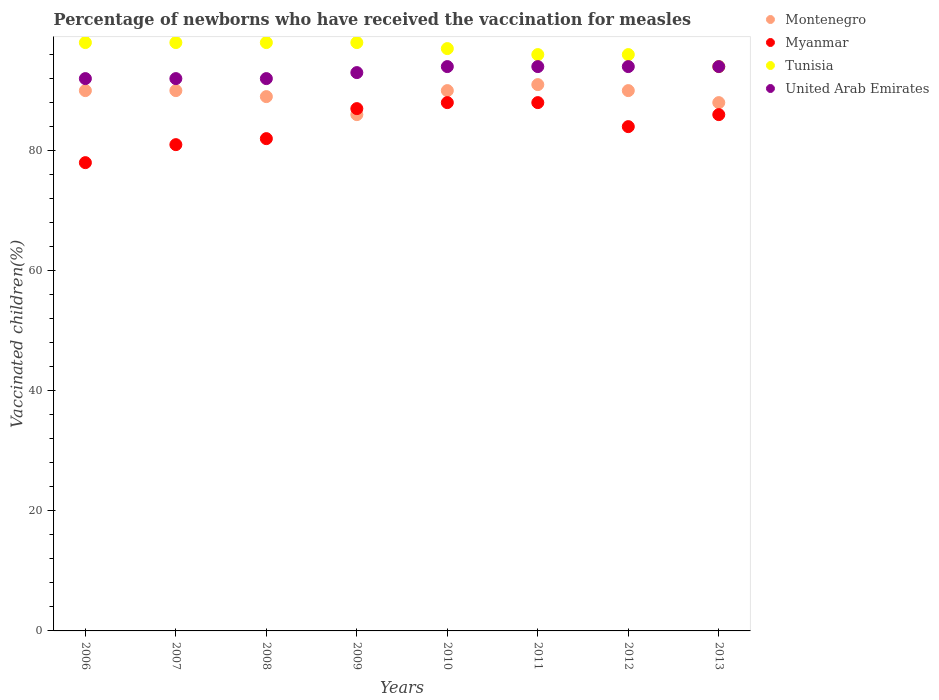How many different coloured dotlines are there?
Provide a short and direct response. 4. What is the percentage of vaccinated children in United Arab Emirates in 2009?
Make the answer very short. 93. In which year was the percentage of vaccinated children in Montenegro maximum?
Provide a succinct answer. 2011. What is the total percentage of vaccinated children in Montenegro in the graph?
Provide a short and direct response. 714. What is the difference between the percentage of vaccinated children in Montenegro in 2006 and that in 2010?
Keep it short and to the point. 0. What is the difference between the percentage of vaccinated children in Myanmar in 2011 and the percentage of vaccinated children in United Arab Emirates in 2008?
Keep it short and to the point. -4. What is the average percentage of vaccinated children in Montenegro per year?
Offer a terse response. 89.25. In how many years, is the percentage of vaccinated children in United Arab Emirates greater than 72 %?
Provide a succinct answer. 8. What is the difference between the highest and the second highest percentage of vaccinated children in Myanmar?
Offer a very short reply. 0. In how many years, is the percentage of vaccinated children in Montenegro greater than the average percentage of vaccinated children in Montenegro taken over all years?
Offer a very short reply. 5. Is the sum of the percentage of vaccinated children in United Arab Emirates in 2008 and 2009 greater than the maximum percentage of vaccinated children in Myanmar across all years?
Your response must be concise. Yes. Is it the case that in every year, the sum of the percentage of vaccinated children in United Arab Emirates and percentage of vaccinated children in Myanmar  is greater than the sum of percentage of vaccinated children in Montenegro and percentage of vaccinated children in Tunisia?
Offer a very short reply. No. Is the percentage of vaccinated children in Montenegro strictly less than the percentage of vaccinated children in Myanmar over the years?
Keep it short and to the point. No. How many dotlines are there?
Your response must be concise. 4. What is the difference between two consecutive major ticks on the Y-axis?
Your answer should be compact. 20. Does the graph contain any zero values?
Keep it short and to the point. No. How are the legend labels stacked?
Your answer should be compact. Vertical. What is the title of the graph?
Keep it short and to the point. Percentage of newborns who have received the vaccination for measles. Does "Luxembourg" appear as one of the legend labels in the graph?
Make the answer very short. No. What is the label or title of the X-axis?
Your answer should be compact. Years. What is the label or title of the Y-axis?
Ensure brevity in your answer.  Vaccinated children(%). What is the Vaccinated children(%) of Montenegro in 2006?
Your answer should be very brief. 90. What is the Vaccinated children(%) in Myanmar in 2006?
Offer a very short reply. 78. What is the Vaccinated children(%) in United Arab Emirates in 2006?
Your response must be concise. 92. What is the Vaccinated children(%) of Montenegro in 2007?
Offer a very short reply. 90. What is the Vaccinated children(%) of Tunisia in 2007?
Your answer should be very brief. 98. What is the Vaccinated children(%) in United Arab Emirates in 2007?
Keep it short and to the point. 92. What is the Vaccinated children(%) in Montenegro in 2008?
Your answer should be very brief. 89. What is the Vaccinated children(%) in United Arab Emirates in 2008?
Offer a terse response. 92. What is the Vaccinated children(%) of Montenegro in 2009?
Your answer should be compact. 86. What is the Vaccinated children(%) in Myanmar in 2009?
Give a very brief answer. 87. What is the Vaccinated children(%) of Tunisia in 2009?
Offer a terse response. 98. What is the Vaccinated children(%) of United Arab Emirates in 2009?
Provide a succinct answer. 93. What is the Vaccinated children(%) of Myanmar in 2010?
Offer a terse response. 88. What is the Vaccinated children(%) of Tunisia in 2010?
Your answer should be very brief. 97. What is the Vaccinated children(%) of United Arab Emirates in 2010?
Provide a short and direct response. 94. What is the Vaccinated children(%) in Montenegro in 2011?
Your answer should be compact. 91. What is the Vaccinated children(%) in Tunisia in 2011?
Offer a terse response. 96. What is the Vaccinated children(%) in United Arab Emirates in 2011?
Your answer should be compact. 94. What is the Vaccinated children(%) in Montenegro in 2012?
Your answer should be compact. 90. What is the Vaccinated children(%) in Myanmar in 2012?
Provide a short and direct response. 84. What is the Vaccinated children(%) in Tunisia in 2012?
Offer a very short reply. 96. What is the Vaccinated children(%) in United Arab Emirates in 2012?
Keep it short and to the point. 94. What is the Vaccinated children(%) in Montenegro in 2013?
Ensure brevity in your answer.  88. What is the Vaccinated children(%) of Tunisia in 2013?
Your answer should be compact. 94. What is the Vaccinated children(%) of United Arab Emirates in 2013?
Your response must be concise. 94. Across all years, what is the maximum Vaccinated children(%) of Montenegro?
Give a very brief answer. 91. Across all years, what is the maximum Vaccinated children(%) of Tunisia?
Offer a very short reply. 98. Across all years, what is the maximum Vaccinated children(%) of United Arab Emirates?
Offer a very short reply. 94. Across all years, what is the minimum Vaccinated children(%) of Montenegro?
Provide a short and direct response. 86. Across all years, what is the minimum Vaccinated children(%) in Tunisia?
Your answer should be compact. 94. Across all years, what is the minimum Vaccinated children(%) of United Arab Emirates?
Your answer should be very brief. 92. What is the total Vaccinated children(%) of Montenegro in the graph?
Your answer should be very brief. 714. What is the total Vaccinated children(%) of Myanmar in the graph?
Provide a short and direct response. 674. What is the total Vaccinated children(%) of Tunisia in the graph?
Make the answer very short. 775. What is the total Vaccinated children(%) in United Arab Emirates in the graph?
Provide a short and direct response. 745. What is the difference between the Vaccinated children(%) in Montenegro in 2006 and that in 2007?
Offer a terse response. 0. What is the difference between the Vaccinated children(%) in United Arab Emirates in 2006 and that in 2007?
Your response must be concise. 0. What is the difference between the Vaccinated children(%) of Montenegro in 2006 and that in 2008?
Your answer should be compact. 1. What is the difference between the Vaccinated children(%) of Tunisia in 2006 and that in 2009?
Provide a short and direct response. 0. What is the difference between the Vaccinated children(%) in Myanmar in 2006 and that in 2010?
Your answer should be very brief. -10. What is the difference between the Vaccinated children(%) of Montenegro in 2006 and that in 2011?
Your answer should be compact. -1. What is the difference between the Vaccinated children(%) in Myanmar in 2006 and that in 2011?
Keep it short and to the point. -10. What is the difference between the Vaccinated children(%) in Tunisia in 2006 and that in 2011?
Ensure brevity in your answer.  2. What is the difference between the Vaccinated children(%) in United Arab Emirates in 2006 and that in 2011?
Offer a terse response. -2. What is the difference between the Vaccinated children(%) in Myanmar in 2006 and that in 2012?
Keep it short and to the point. -6. What is the difference between the Vaccinated children(%) in Montenegro in 2007 and that in 2008?
Offer a terse response. 1. What is the difference between the Vaccinated children(%) in Tunisia in 2007 and that in 2008?
Provide a succinct answer. 0. What is the difference between the Vaccinated children(%) in Montenegro in 2007 and that in 2009?
Keep it short and to the point. 4. What is the difference between the Vaccinated children(%) in Tunisia in 2007 and that in 2009?
Offer a very short reply. 0. What is the difference between the Vaccinated children(%) of United Arab Emirates in 2007 and that in 2009?
Your answer should be very brief. -1. What is the difference between the Vaccinated children(%) in Tunisia in 2007 and that in 2010?
Your answer should be very brief. 1. What is the difference between the Vaccinated children(%) in United Arab Emirates in 2007 and that in 2010?
Keep it short and to the point. -2. What is the difference between the Vaccinated children(%) in Montenegro in 2007 and that in 2011?
Offer a very short reply. -1. What is the difference between the Vaccinated children(%) of Myanmar in 2007 and that in 2011?
Your answer should be very brief. -7. What is the difference between the Vaccinated children(%) of United Arab Emirates in 2007 and that in 2011?
Ensure brevity in your answer.  -2. What is the difference between the Vaccinated children(%) in Montenegro in 2007 and that in 2012?
Make the answer very short. 0. What is the difference between the Vaccinated children(%) in Myanmar in 2007 and that in 2012?
Offer a very short reply. -3. What is the difference between the Vaccinated children(%) in Montenegro in 2007 and that in 2013?
Offer a terse response. 2. What is the difference between the Vaccinated children(%) in Myanmar in 2007 and that in 2013?
Your answer should be compact. -5. What is the difference between the Vaccinated children(%) of Montenegro in 2008 and that in 2009?
Offer a very short reply. 3. What is the difference between the Vaccinated children(%) in Myanmar in 2008 and that in 2009?
Your answer should be very brief. -5. What is the difference between the Vaccinated children(%) in Montenegro in 2008 and that in 2010?
Your answer should be compact. -1. What is the difference between the Vaccinated children(%) of Tunisia in 2008 and that in 2010?
Offer a terse response. 1. What is the difference between the Vaccinated children(%) in United Arab Emirates in 2008 and that in 2010?
Your response must be concise. -2. What is the difference between the Vaccinated children(%) in Montenegro in 2008 and that in 2011?
Offer a terse response. -2. What is the difference between the Vaccinated children(%) of Tunisia in 2008 and that in 2011?
Give a very brief answer. 2. What is the difference between the Vaccinated children(%) in Montenegro in 2008 and that in 2012?
Offer a very short reply. -1. What is the difference between the Vaccinated children(%) of Myanmar in 2008 and that in 2012?
Provide a succinct answer. -2. What is the difference between the Vaccinated children(%) of Tunisia in 2008 and that in 2012?
Your answer should be compact. 2. What is the difference between the Vaccinated children(%) of Tunisia in 2008 and that in 2013?
Ensure brevity in your answer.  4. What is the difference between the Vaccinated children(%) of United Arab Emirates in 2009 and that in 2010?
Make the answer very short. -1. What is the difference between the Vaccinated children(%) of Myanmar in 2009 and that in 2011?
Your response must be concise. -1. What is the difference between the Vaccinated children(%) of Tunisia in 2009 and that in 2011?
Provide a short and direct response. 2. What is the difference between the Vaccinated children(%) of United Arab Emirates in 2009 and that in 2011?
Your answer should be very brief. -1. What is the difference between the Vaccinated children(%) in Montenegro in 2009 and that in 2012?
Give a very brief answer. -4. What is the difference between the Vaccinated children(%) in Myanmar in 2009 and that in 2012?
Your answer should be very brief. 3. What is the difference between the Vaccinated children(%) in Montenegro in 2009 and that in 2013?
Provide a short and direct response. -2. What is the difference between the Vaccinated children(%) of United Arab Emirates in 2009 and that in 2013?
Offer a very short reply. -1. What is the difference between the Vaccinated children(%) of Tunisia in 2010 and that in 2011?
Offer a very short reply. 1. What is the difference between the Vaccinated children(%) in Myanmar in 2010 and that in 2012?
Keep it short and to the point. 4. What is the difference between the Vaccinated children(%) in United Arab Emirates in 2010 and that in 2012?
Ensure brevity in your answer.  0. What is the difference between the Vaccinated children(%) of Myanmar in 2010 and that in 2013?
Offer a terse response. 2. What is the difference between the Vaccinated children(%) of Myanmar in 2011 and that in 2012?
Give a very brief answer. 4. What is the difference between the Vaccinated children(%) of Tunisia in 2011 and that in 2012?
Your response must be concise. 0. What is the difference between the Vaccinated children(%) in Montenegro in 2011 and that in 2013?
Offer a very short reply. 3. What is the difference between the Vaccinated children(%) in Montenegro in 2012 and that in 2013?
Your answer should be very brief. 2. What is the difference between the Vaccinated children(%) in Myanmar in 2012 and that in 2013?
Offer a terse response. -2. What is the difference between the Vaccinated children(%) in Montenegro in 2006 and the Vaccinated children(%) in Myanmar in 2007?
Give a very brief answer. 9. What is the difference between the Vaccinated children(%) in Montenegro in 2006 and the Vaccinated children(%) in Tunisia in 2007?
Your response must be concise. -8. What is the difference between the Vaccinated children(%) of Myanmar in 2006 and the Vaccinated children(%) of Tunisia in 2007?
Your response must be concise. -20. What is the difference between the Vaccinated children(%) in Myanmar in 2006 and the Vaccinated children(%) in United Arab Emirates in 2007?
Keep it short and to the point. -14. What is the difference between the Vaccinated children(%) of Myanmar in 2006 and the Vaccinated children(%) of Tunisia in 2008?
Offer a very short reply. -20. What is the difference between the Vaccinated children(%) in Tunisia in 2006 and the Vaccinated children(%) in United Arab Emirates in 2008?
Your response must be concise. 6. What is the difference between the Vaccinated children(%) in Montenegro in 2006 and the Vaccinated children(%) in Myanmar in 2009?
Your response must be concise. 3. What is the difference between the Vaccinated children(%) of Montenegro in 2006 and the Vaccinated children(%) of Tunisia in 2009?
Your answer should be very brief. -8. What is the difference between the Vaccinated children(%) of Myanmar in 2006 and the Vaccinated children(%) of Tunisia in 2009?
Offer a very short reply. -20. What is the difference between the Vaccinated children(%) of Tunisia in 2006 and the Vaccinated children(%) of United Arab Emirates in 2009?
Offer a terse response. 5. What is the difference between the Vaccinated children(%) of Montenegro in 2006 and the Vaccinated children(%) of Myanmar in 2010?
Provide a short and direct response. 2. What is the difference between the Vaccinated children(%) of Myanmar in 2006 and the Vaccinated children(%) of United Arab Emirates in 2010?
Your answer should be compact. -16. What is the difference between the Vaccinated children(%) of Montenegro in 2006 and the Vaccinated children(%) of Tunisia in 2011?
Your answer should be very brief. -6. What is the difference between the Vaccinated children(%) in Montenegro in 2006 and the Vaccinated children(%) in United Arab Emirates in 2011?
Your response must be concise. -4. What is the difference between the Vaccinated children(%) in Myanmar in 2006 and the Vaccinated children(%) in Tunisia in 2011?
Offer a terse response. -18. What is the difference between the Vaccinated children(%) of Myanmar in 2006 and the Vaccinated children(%) of United Arab Emirates in 2011?
Give a very brief answer. -16. What is the difference between the Vaccinated children(%) of Myanmar in 2006 and the Vaccinated children(%) of Tunisia in 2012?
Make the answer very short. -18. What is the difference between the Vaccinated children(%) of Montenegro in 2006 and the Vaccinated children(%) of United Arab Emirates in 2013?
Provide a short and direct response. -4. What is the difference between the Vaccinated children(%) of Tunisia in 2006 and the Vaccinated children(%) of United Arab Emirates in 2013?
Give a very brief answer. 4. What is the difference between the Vaccinated children(%) of Montenegro in 2007 and the Vaccinated children(%) of Myanmar in 2008?
Provide a succinct answer. 8. What is the difference between the Vaccinated children(%) of Montenegro in 2007 and the Vaccinated children(%) of Tunisia in 2008?
Your response must be concise. -8. What is the difference between the Vaccinated children(%) of Montenegro in 2007 and the Vaccinated children(%) of United Arab Emirates in 2008?
Ensure brevity in your answer.  -2. What is the difference between the Vaccinated children(%) of Tunisia in 2007 and the Vaccinated children(%) of United Arab Emirates in 2008?
Keep it short and to the point. 6. What is the difference between the Vaccinated children(%) in Montenegro in 2007 and the Vaccinated children(%) in Myanmar in 2009?
Your answer should be compact. 3. What is the difference between the Vaccinated children(%) of Montenegro in 2007 and the Vaccinated children(%) of Tunisia in 2009?
Ensure brevity in your answer.  -8. What is the difference between the Vaccinated children(%) in Montenegro in 2007 and the Vaccinated children(%) in United Arab Emirates in 2009?
Your answer should be very brief. -3. What is the difference between the Vaccinated children(%) in Montenegro in 2007 and the Vaccinated children(%) in United Arab Emirates in 2010?
Provide a short and direct response. -4. What is the difference between the Vaccinated children(%) of Myanmar in 2007 and the Vaccinated children(%) of United Arab Emirates in 2010?
Keep it short and to the point. -13. What is the difference between the Vaccinated children(%) of Tunisia in 2007 and the Vaccinated children(%) of United Arab Emirates in 2010?
Offer a terse response. 4. What is the difference between the Vaccinated children(%) of Montenegro in 2007 and the Vaccinated children(%) of United Arab Emirates in 2011?
Offer a very short reply. -4. What is the difference between the Vaccinated children(%) of Montenegro in 2007 and the Vaccinated children(%) of Myanmar in 2012?
Offer a terse response. 6. What is the difference between the Vaccinated children(%) in Myanmar in 2007 and the Vaccinated children(%) in Tunisia in 2012?
Keep it short and to the point. -15. What is the difference between the Vaccinated children(%) of Montenegro in 2007 and the Vaccinated children(%) of Myanmar in 2013?
Your answer should be very brief. 4. What is the difference between the Vaccinated children(%) of Montenegro in 2008 and the Vaccinated children(%) of Tunisia in 2009?
Your answer should be very brief. -9. What is the difference between the Vaccinated children(%) of Myanmar in 2008 and the Vaccinated children(%) of United Arab Emirates in 2009?
Provide a succinct answer. -11. What is the difference between the Vaccinated children(%) in Tunisia in 2008 and the Vaccinated children(%) in United Arab Emirates in 2009?
Provide a succinct answer. 5. What is the difference between the Vaccinated children(%) of Montenegro in 2008 and the Vaccinated children(%) of United Arab Emirates in 2010?
Ensure brevity in your answer.  -5. What is the difference between the Vaccinated children(%) of Myanmar in 2008 and the Vaccinated children(%) of Tunisia in 2010?
Your answer should be very brief. -15. What is the difference between the Vaccinated children(%) in Montenegro in 2008 and the Vaccinated children(%) in Tunisia in 2011?
Provide a short and direct response. -7. What is the difference between the Vaccinated children(%) of Myanmar in 2008 and the Vaccinated children(%) of Tunisia in 2011?
Keep it short and to the point. -14. What is the difference between the Vaccinated children(%) of Myanmar in 2008 and the Vaccinated children(%) of United Arab Emirates in 2011?
Provide a succinct answer. -12. What is the difference between the Vaccinated children(%) in Montenegro in 2008 and the Vaccinated children(%) in United Arab Emirates in 2012?
Provide a short and direct response. -5. What is the difference between the Vaccinated children(%) of Myanmar in 2008 and the Vaccinated children(%) of Tunisia in 2012?
Your response must be concise. -14. What is the difference between the Vaccinated children(%) of Myanmar in 2008 and the Vaccinated children(%) of United Arab Emirates in 2012?
Your answer should be very brief. -12. What is the difference between the Vaccinated children(%) of Tunisia in 2008 and the Vaccinated children(%) of United Arab Emirates in 2013?
Offer a terse response. 4. What is the difference between the Vaccinated children(%) in Myanmar in 2009 and the Vaccinated children(%) in Tunisia in 2010?
Give a very brief answer. -10. What is the difference between the Vaccinated children(%) in Myanmar in 2009 and the Vaccinated children(%) in United Arab Emirates in 2010?
Give a very brief answer. -7. What is the difference between the Vaccinated children(%) of Montenegro in 2009 and the Vaccinated children(%) of United Arab Emirates in 2011?
Provide a short and direct response. -8. What is the difference between the Vaccinated children(%) of Montenegro in 2009 and the Vaccinated children(%) of Myanmar in 2012?
Give a very brief answer. 2. What is the difference between the Vaccinated children(%) of Montenegro in 2009 and the Vaccinated children(%) of United Arab Emirates in 2012?
Make the answer very short. -8. What is the difference between the Vaccinated children(%) of Myanmar in 2009 and the Vaccinated children(%) of Tunisia in 2012?
Provide a succinct answer. -9. What is the difference between the Vaccinated children(%) of Tunisia in 2009 and the Vaccinated children(%) of United Arab Emirates in 2012?
Make the answer very short. 4. What is the difference between the Vaccinated children(%) in Montenegro in 2009 and the Vaccinated children(%) in Myanmar in 2013?
Ensure brevity in your answer.  0. What is the difference between the Vaccinated children(%) of Myanmar in 2009 and the Vaccinated children(%) of Tunisia in 2013?
Provide a short and direct response. -7. What is the difference between the Vaccinated children(%) of Montenegro in 2010 and the Vaccinated children(%) of Myanmar in 2011?
Your answer should be compact. 2. What is the difference between the Vaccinated children(%) in Montenegro in 2010 and the Vaccinated children(%) in Tunisia in 2011?
Make the answer very short. -6. What is the difference between the Vaccinated children(%) in Montenegro in 2010 and the Vaccinated children(%) in United Arab Emirates in 2012?
Provide a short and direct response. -4. What is the difference between the Vaccinated children(%) in Myanmar in 2010 and the Vaccinated children(%) in Tunisia in 2012?
Offer a terse response. -8. What is the difference between the Vaccinated children(%) of Myanmar in 2010 and the Vaccinated children(%) of United Arab Emirates in 2012?
Ensure brevity in your answer.  -6. What is the difference between the Vaccinated children(%) in Tunisia in 2010 and the Vaccinated children(%) in United Arab Emirates in 2012?
Your answer should be very brief. 3. What is the difference between the Vaccinated children(%) of Montenegro in 2010 and the Vaccinated children(%) of Tunisia in 2013?
Your response must be concise. -4. What is the difference between the Vaccinated children(%) of Montenegro in 2010 and the Vaccinated children(%) of United Arab Emirates in 2013?
Provide a short and direct response. -4. What is the difference between the Vaccinated children(%) of Myanmar in 2010 and the Vaccinated children(%) of Tunisia in 2013?
Give a very brief answer. -6. What is the difference between the Vaccinated children(%) of Myanmar in 2011 and the Vaccinated children(%) of Tunisia in 2012?
Offer a terse response. -8. What is the difference between the Vaccinated children(%) in Tunisia in 2011 and the Vaccinated children(%) in United Arab Emirates in 2012?
Make the answer very short. 2. What is the difference between the Vaccinated children(%) of Montenegro in 2011 and the Vaccinated children(%) of Myanmar in 2013?
Your answer should be compact. 5. What is the difference between the Vaccinated children(%) in Montenegro in 2011 and the Vaccinated children(%) in United Arab Emirates in 2013?
Ensure brevity in your answer.  -3. What is the difference between the Vaccinated children(%) in Myanmar in 2011 and the Vaccinated children(%) in United Arab Emirates in 2013?
Offer a terse response. -6. What is the difference between the Vaccinated children(%) in Montenegro in 2012 and the Vaccinated children(%) in Myanmar in 2013?
Your answer should be compact. 4. What is the difference between the Vaccinated children(%) of Montenegro in 2012 and the Vaccinated children(%) of United Arab Emirates in 2013?
Your answer should be very brief. -4. What is the difference between the Vaccinated children(%) of Myanmar in 2012 and the Vaccinated children(%) of Tunisia in 2013?
Your answer should be very brief. -10. What is the difference between the Vaccinated children(%) of Myanmar in 2012 and the Vaccinated children(%) of United Arab Emirates in 2013?
Make the answer very short. -10. What is the difference between the Vaccinated children(%) of Tunisia in 2012 and the Vaccinated children(%) of United Arab Emirates in 2013?
Your answer should be very brief. 2. What is the average Vaccinated children(%) of Montenegro per year?
Your answer should be very brief. 89.25. What is the average Vaccinated children(%) in Myanmar per year?
Your response must be concise. 84.25. What is the average Vaccinated children(%) in Tunisia per year?
Provide a short and direct response. 96.88. What is the average Vaccinated children(%) of United Arab Emirates per year?
Give a very brief answer. 93.12. In the year 2006, what is the difference between the Vaccinated children(%) of Montenegro and Vaccinated children(%) of Tunisia?
Your answer should be compact. -8. In the year 2006, what is the difference between the Vaccinated children(%) of Montenegro and Vaccinated children(%) of United Arab Emirates?
Provide a succinct answer. -2. In the year 2006, what is the difference between the Vaccinated children(%) in Myanmar and Vaccinated children(%) in United Arab Emirates?
Provide a succinct answer. -14. In the year 2007, what is the difference between the Vaccinated children(%) in Montenegro and Vaccinated children(%) in Myanmar?
Make the answer very short. 9. In the year 2007, what is the difference between the Vaccinated children(%) in Montenegro and Vaccinated children(%) in United Arab Emirates?
Keep it short and to the point. -2. In the year 2007, what is the difference between the Vaccinated children(%) in Tunisia and Vaccinated children(%) in United Arab Emirates?
Provide a short and direct response. 6. In the year 2008, what is the difference between the Vaccinated children(%) in Montenegro and Vaccinated children(%) in United Arab Emirates?
Make the answer very short. -3. In the year 2008, what is the difference between the Vaccinated children(%) in Myanmar and Vaccinated children(%) in Tunisia?
Your response must be concise. -16. In the year 2008, what is the difference between the Vaccinated children(%) in Tunisia and Vaccinated children(%) in United Arab Emirates?
Ensure brevity in your answer.  6. In the year 2009, what is the difference between the Vaccinated children(%) in Montenegro and Vaccinated children(%) in Tunisia?
Offer a terse response. -12. In the year 2009, what is the difference between the Vaccinated children(%) of Tunisia and Vaccinated children(%) of United Arab Emirates?
Keep it short and to the point. 5. In the year 2010, what is the difference between the Vaccinated children(%) of Montenegro and Vaccinated children(%) of Tunisia?
Offer a very short reply. -7. In the year 2010, what is the difference between the Vaccinated children(%) in Montenegro and Vaccinated children(%) in United Arab Emirates?
Your answer should be compact. -4. In the year 2010, what is the difference between the Vaccinated children(%) in Myanmar and Vaccinated children(%) in Tunisia?
Provide a succinct answer. -9. In the year 2010, what is the difference between the Vaccinated children(%) in Myanmar and Vaccinated children(%) in United Arab Emirates?
Keep it short and to the point. -6. In the year 2010, what is the difference between the Vaccinated children(%) of Tunisia and Vaccinated children(%) of United Arab Emirates?
Ensure brevity in your answer.  3. In the year 2011, what is the difference between the Vaccinated children(%) of Montenegro and Vaccinated children(%) of Myanmar?
Offer a very short reply. 3. In the year 2011, what is the difference between the Vaccinated children(%) of Montenegro and Vaccinated children(%) of Tunisia?
Provide a short and direct response. -5. In the year 2011, what is the difference between the Vaccinated children(%) in Montenegro and Vaccinated children(%) in United Arab Emirates?
Ensure brevity in your answer.  -3. In the year 2011, what is the difference between the Vaccinated children(%) in Myanmar and Vaccinated children(%) in Tunisia?
Offer a very short reply. -8. In the year 2011, what is the difference between the Vaccinated children(%) in Myanmar and Vaccinated children(%) in United Arab Emirates?
Keep it short and to the point. -6. In the year 2012, what is the difference between the Vaccinated children(%) in Montenegro and Vaccinated children(%) in Myanmar?
Your answer should be compact. 6. In the year 2012, what is the difference between the Vaccinated children(%) of Montenegro and Vaccinated children(%) of United Arab Emirates?
Offer a very short reply. -4. In the year 2012, what is the difference between the Vaccinated children(%) in Myanmar and Vaccinated children(%) in United Arab Emirates?
Keep it short and to the point. -10. In the year 2012, what is the difference between the Vaccinated children(%) in Tunisia and Vaccinated children(%) in United Arab Emirates?
Provide a short and direct response. 2. In the year 2013, what is the difference between the Vaccinated children(%) in Montenegro and Vaccinated children(%) in Myanmar?
Offer a terse response. 2. In the year 2013, what is the difference between the Vaccinated children(%) of Myanmar and Vaccinated children(%) of United Arab Emirates?
Provide a succinct answer. -8. What is the ratio of the Vaccinated children(%) of Montenegro in 2006 to that in 2007?
Make the answer very short. 1. What is the ratio of the Vaccinated children(%) of Myanmar in 2006 to that in 2007?
Your answer should be very brief. 0.96. What is the ratio of the Vaccinated children(%) of United Arab Emirates in 2006 to that in 2007?
Your response must be concise. 1. What is the ratio of the Vaccinated children(%) of Montenegro in 2006 to that in 2008?
Your response must be concise. 1.01. What is the ratio of the Vaccinated children(%) of Myanmar in 2006 to that in 2008?
Make the answer very short. 0.95. What is the ratio of the Vaccinated children(%) of United Arab Emirates in 2006 to that in 2008?
Offer a terse response. 1. What is the ratio of the Vaccinated children(%) of Montenegro in 2006 to that in 2009?
Ensure brevity in your answer.  1.05. What is the ratio of the Vaccinated children(%) of Myanmar in 2006 to that in 2009?
Your answer should be very brief. 0.9. What is the ratio of the Vaccinated children(%) in United Arab Emirates in 2006 to that in 2009?
Give a very brief answer. 0.99. What is the ratio of the Vaccinated children(%) of Myanmar in 2006 to that in 2010?
Ensure brevity in your answer.  0.89. What is the ratio of the Vaccinated children(%) in Tunisia in 2006 to that in 2010?
Offer a very short reply. 1.01. What is the ratio of the Vaccinated children(%) in United Arab Emirates in 2006 to that in 2010?
Offer a terse response. 0.98. What is the ratio of the Vaccinated children(%) in Myanmar in 2006 to that in 2011?
Your response must be concise. 0.89. What is the ratio of the Vaccinated children(%) of Tunisia in 2006 to that in 2011?
Keep it short and to the point. 1.02. What is the ratio of the Vaccinated children(%) of United Arab Emirates in 2006 to that in 2011?
Provide a succinct answer. 0.98. What is the ratio of the Vaccinated children(%) in Montenegro in 2006 to that in 2012?
Your answer should be compact. 1. What is the ratio of the Vaccinated children(%) of Tunisia in 2006 to that in 2012?
Your response must be concise. 1.02. What is the ratio of the Vaccinated children(%) in United Arab Emirates in 2006 to that in 2012?
Give a very brief answer. 0.98. What is the ratio of the Vaccinated children(%) of Montenegro in 2006 to that in 2013?
Ensure brevity in your answer.  1.02. What is the ratio of the Vaccinated children(%) in Myanmar in 2006 to that in 2013?
Keep it short and to the point. 0.91. What is the ratio of the Vaccinated children(%) of Tunisia in 2006 to that in 2013?
Keep it short and to the point. 1.04. What is the ratio of the Vaccinated children(%) of United Arab Emirates in 2006 to that in 2013?
Offer a terse response. 0.98. What is the ratio of the Vaccinated children(%) in Montenegro in 2007 to that in 2008?
Keep it short and to the point. 1.01. What is the ratio of the Vaccinated children(%) of Tunisia in 2007 to that in 2008?
Your answer should be very brief. 1. What is the ratio of the Vaccinated children(%) in United Arab Emirates in 2007 to that in 2008?
Offer a terse response. 1. What is the ratio of the Vaccinated children(%) in Montenegro in 2007 to that in 2009?
Make the answer very short. 1.05. What is the ratio of the Vaccinated children(%) in Myanmar in 2007 to that in 2009?
Offer a very short reply. 0.93. What is the ratio of the Vaccinated children(%) of Tunisia in 2007 to that in 2009?
Ensure brevity in your answer.  1. What is the ratio of the Vaccinated children(%) of Myanmar in 2007 to that in 2010?
Give a very brief answer. 0.92. What is the ratio of the Vaccinated children(%) of Tunisia in 2007 to that in 2010?
Give a very brief answer. 1.01. What is the ratio of the Vaccinated children(%) in United Arab Emirates in 2007 to that in 2010?
Provide a short and direct response. 0.98. What is the ratio of the Vaccinated children(%) of Montenegro in 2007 to that in 2011?
Your response must be concise. 0.99. What is the ratio of the Vaccinated children(%) of Myanmar in 2007 to that in 2011?
Give a very brief answer. 0.92. What is the ratio of the Vaccinated children(%) in Tunisia in 2007 to that in 2011?
Provide a short and direct response. 1.02. What is the ratio of the Vaccinated children(%) of United Arab Emirates in 2007 to that in 2011?
Your answer should be very brief. 0.98. What is the ratio of the Vaccinated children(%) of Montenegro in 2007 to that in 2012?
Make the answer very short. 1. What is the ratio of the Vaccinated children(%) in Myanmar in 2007 to that in 2012?
Ensure brevity in your answer.  0.96. What is the ratio of the Vaccinated children(%) of Tunisia in 2007 to that in 2012?
Provide a succinct answer. 1.02. What is the ratio of the Vaccinated children(%) of United Arab Emirates in 2007 to that in 2012?
Offer a very short reply. 0.98. What is the ratio of the Vaccinated children(%) in Montenegro in 2007 to that in 2013?
Ensure brevity in your answer.  1.02. What is the ratio of the Vaccinated children(%) in Myanmar in 2007 to that in 2013?
Offer a very short reply. 0.94. What is the ratio of the Vaccinated children(%) in Tunisia in 2007 to that in 2013?
Provide a succinct answer. 1.04. What is the ratio of the Vaccinated children(%) in United Arab Emirates in 2007 to that in 2013?
Offer a terse response. 0.98. What is the ratio of the Vaccinated children(%) of Montenegro in 2008 to that in 2009?
Your answer should be very brief. 1.03. What is the ratio of the Vaccinated children(%) of Myanmar in 2008 to that in 2009?
Your answer should be very brief. 0.94. What is the ratio of the Vaccinated children(%) of Tunisia in 2008 to that in 2009?
Your answer should be compact. 1. What is the ratio of the Vaccinated children(%) of United Arab Emirates in 2008 to that in 2009?
Give a very brief answer. 0.99. What is the ratio of the Vaccinated children(%) in Montenegro in 2008 to that in 2010?
Offer a terse response. 0.99. What is the ratio of the Vaccinated children(%) of Myanmar in 2008 to that in 2010?
Give a very brief answer. 0.93. What is the ratio of the Vaccinated children(%) of Tunisia in 2008 to that in 2010?
Your answer should be very brief. 1.01. What is the ratio of the Vaccinated children(%) of United Arab Emirates in 2008 to that in 2010?
Make the answer very short. 0.98. What is the ratio of the Vaccinated children(%) of Myanmar in 2008 to that in 2011?
Provide a succinct answer. 0.93. What is the ratio of the Vaccinated children(%) of Tunisia in 2008 to that in 2011?
Provide a succinct answer. 1.02. What is the ratio of the Vaccinated children(%) of United Arab Emirates in 2008 to that in 2011?
Your response must be concise. 0.98. What is the ratio of the Vaccinated children(%) in Montenegro in 2008 to that in 2012?
Offer a terse response. 0.99. What is the ratio of the Vaccinated children(%) of Myanmar in 2008 to that in 2012?
Give a very brief answer. 0.98. What is the ratio of the Vaccinated children(%) in Tunisia in 2008 to that in 2012?
Offer a very short reply. 1.02. What is the ratio of the Vaccinated children(%) of United Arab Emirates in 2008 to that in 2012?
Give a very brief answer. 0.98. What is the ratio of the Vaccinated children(%) of Montenegro in 2008 to that in 2013?
Provide a short and direct response. 1.01. What is the ratio of the Vaccinated children(%) in Myanmar in 2008 to that in 2013?
Make the answer very short. 0.95. What is the ratio of the Vaccinated children(%) in Tunisia in 2008 to that in 2013?
Keep it short and to the point. 1.04. What is the ratio of the Vaccinated children(%) of United Arab Emirates in 2008 to that in 2013?
Provide a succinct answer. 0.98. What is the ratio of the Vaccinated children(%) in Montenegro in 2009 to that in 2010?
Make the answer very short. 0.96. What is the ratio of the Vaccinated children(%) of Tunisia in 2009 to that in 2010?
Your answer should be very brief. 1.01. What is the ratio of the Vaccinated children(%) in United Arab Emirates in 2009 to that in 2010?
Offer a terse response. 0.99. What is the ratio of the Vaccinated children(%) in Montenegro in 2009 to that in 2011?
Ensure brevity in your answer.  0.95. What is the ratio of the Vaccinated children(%) in Tunisia in 2009 to that in 2011?
Your answer should be very brief. 1.02. What is the ratio of the Vaccinated children(%) of Montenegro in 2009 to that in 2012?
Keep it short and to the point. 0.96. What is the ratio of the Vaccinated children(%) in Myanmar in 2009 to that in 2012?
Your answer should be very brief. 1.04. What is the ratio of the Vaccinated children(%) in Tunisia in 2009 to that in 2012?
Your response must be concise. 1.02. What is the ratio of the Vaccinated children(%) in Montenegro in 2009 to that in 2013?
Your response must be concise. 0.98. What is the ratio of the Vaccinated children(%) of Myanmar in 2009 to that in 2013?
Provide a short and direct response. 1.01. What is the ratio of the Vaccinated children(%) in Tunisia in 2009 to that in 2013?
Make the answer very short. 1.04. What is the ratio of the Vaccinated children(%) of United Arab Emirates in 2009 to that in 2013?
Make the answer very short. 0.99. What is the ratio of the Vaccinated children(%) in Montenegro in 2010 to that in 2011?
Provide a short and direct response. 0.99. What is the ratio of the Vaccinated children(%) of Tunisia in 2010 to that in 2011?
Your answer should be compact. 1.01. What is the ratio of the Vaccinated children(%) of Myanmar in 2010 to that in 2012?
Your response must be concise. 1.05. What is the ratio of the Vaccinated children(%) of Tunisia in 2010 to that in 2012?
Keep it short and to the point. 1.01. What is the ratio of the Vaccinated children(%) in Montenegro in 2010 to that in 2013?
Your answer should be very brief. 1.02. What is the ratio of the Vaccinated children(%) in Myanmar in 2010 to that in 2013?
Ensure brevity in your answer.  1.02. What is the ratio of the Vaccinated children(%) in Tunisia in 2010 to that in 2013?
Make the answer very short. 1.03. What is the ratio of the Vaccinated children(%) in Montenegro in 2011 to that in 2012?
Give a very brief answer. 1.01. What is the ratio of the Vaccinated children(%) in Myanmar in 2011 to that in 2012?
Offer a very short reply. 1.05. What is the ratio of the Vaccinated children(%) in Montenegro in 2011 to that in 2013?
Make the answer very short. 1.03. What is the ratio of the Vaccinated children(%) of Myanmar in 2011 to that in 2013?
Your answer should be compact. 1.02. What is the ratio of the Vaccinated children(%) in Tunisia in 2011 to that in 2013?
Offer a very short reply. 1.02. What is the ratio of the Vaccinated children(%) of United Arab Emirates in 2011 to that in 2013?
Offer a very short reply. 1. What is the ratio of the Vaccinated children(%) in Montenegro in 2012 to that in 2013?
Ensure brevity in your answer.  1.02. What is the ratio of the Vaccinated children(%) of Myanmar in 2012 to that in 2013?
Give a very brief answer. 0.98. What is the ratio of the Vaccinated children(%) of Tunisia in 2012 to that in 2013?
Provide a succinct answer. 1.02. What is the ratio of the Vaccinated children(%) in United Arab Emirates in 2012 to that in 2013?
Your response must be concise. 1. What is the difference between the highest and the second highest Vaccinated children(%) of Myanmar?
Provide a succinct answer. 0. What is the difference between the highest and the second highest Vaccinated children(%) in Tunisia?
Make the answer very short. 0. What is the difference between the highest and the second highest Vaccinated children(%) of United Arab Emirates?
Your answer should be very brief. 0. What is the difference between the highest and the lowest Vaccinated children(%) of Montenegro?
Keep it short and to the point. 5. What is the difference between the highest and the lowest Vaccinated children(%) of Myanmar?
Provide a short and direct response. 10. 